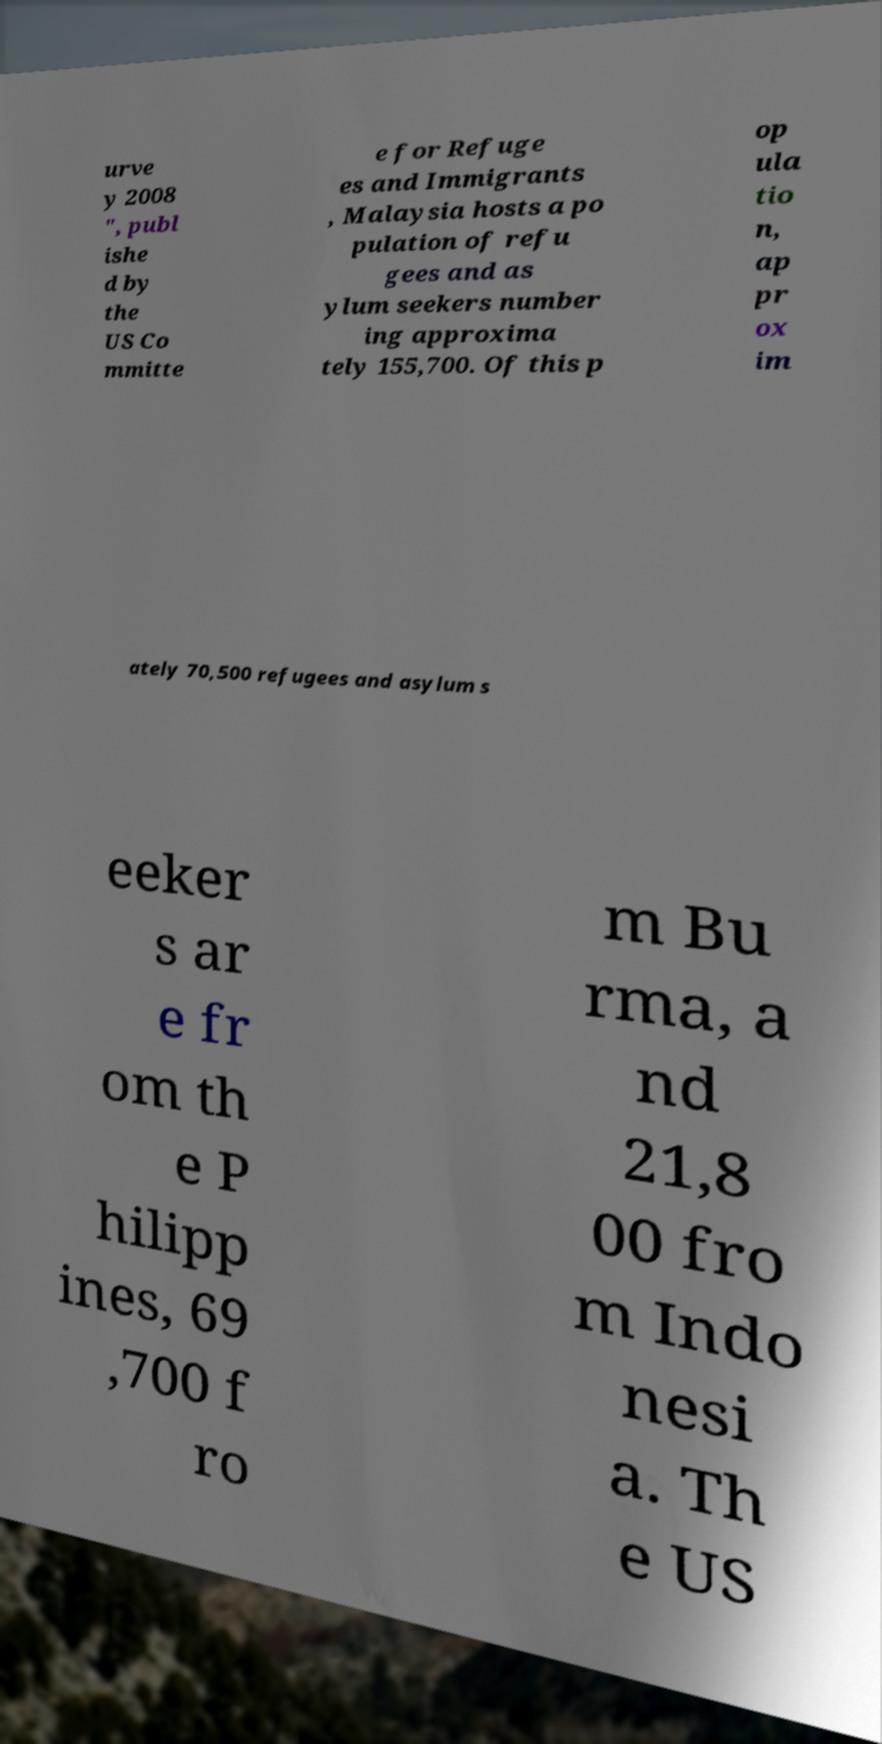For documentation purposes, I need the text within this image transcribed. Could you provide that? urve y 2008 ", publ ishe d by the US Co mmitte e for Refuge es and Immigrants , Malaysia hosts a po pulation of refu gees and as ylum seekers number ing approxima tely 155,700. Of this p op ula tio n, ap pr ox im ately 70,500 refugees and asylum s eeker s ar e fr om th e P hilipp ines, 69 ,700 f ro m Bu rma, a nd 21,8 00 fro m Indo nesi a. Th e US 